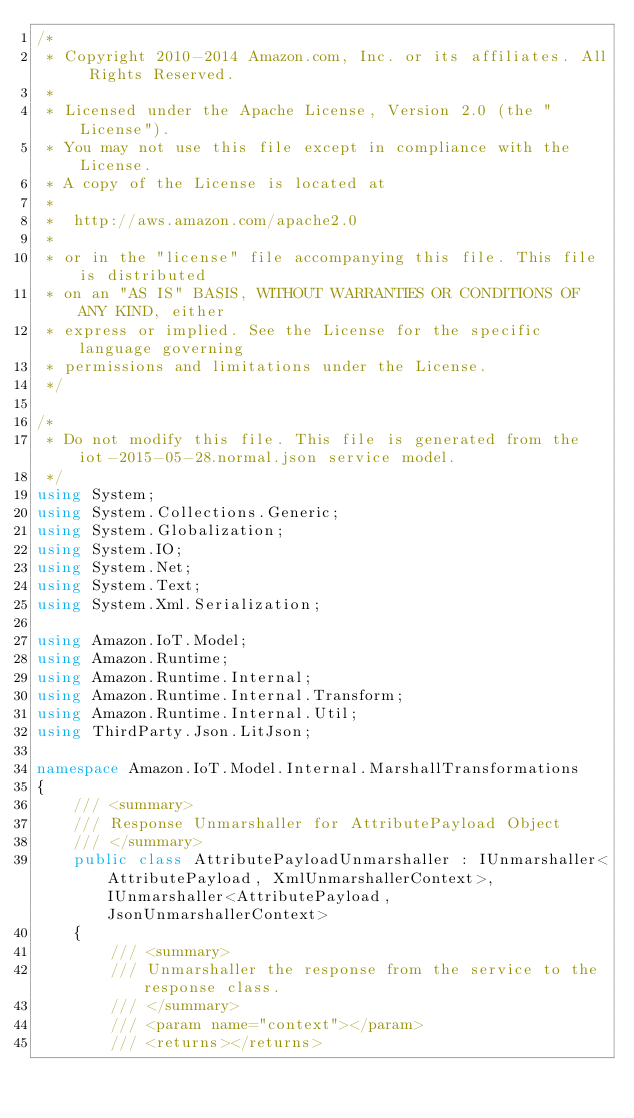<code> <loc_0><loc_0><loc_500><loc_500><_C#_>/*
 * Copyright 2010-2014 Amazon.com, Inc. or its affiliates. All Rights Reserved.
 * 
 * Licensed under the Apache License, Version 2.0 (the "License").
 * You may not use this file except in compliance with the License.
 * A copy of the License is located at
 * 
 *  http://aws.amazon.com/apache2.0
 * 
 * or in the "license" file accompanying this file. This file is distributed
 * on an "AS IS" BASIS, WITHOUT WARRANTIES OR CONDITIONS OF ANY KIND, either
 * express or implied. See the License for the specific language governing
 * permissions and limitations under the License.
 */

/*
 * Do not modify this file. This file is generated from the iot-2015-05-28.normal.json service model.
 */
using System;
using System.Collections.Generic;
using System.Globalization;
using System.IO;
using System.Net;
using System.Text;
using System.Xml.Serialization;

using Amazon.IoT.Model;
using Amazon.Runtime;
using Amazon.Runtime.Internal;
using Amazon.Runtime.Internal.Transform;
using Amazon.Runtime.Internal.Util;
using ThirdParty.Json.LitJson;

namespace Amazon.IoT.Model.Internal.MarshallTransformations
{
    /// <summary>
    /// Response Unmarshaller for AttributePayload Object
    /// </summary>  
    public class AttributePayloadUnmarshaller : IUnmarshaller<AttributePayload, XmlUnmarshallerContext>, IUnmarshaller<AttributePayload, JsonUnmarshallerContext>
    {
        /// <summary>
        /// Unmarshaller the response from the service to the response class.
        /// </summary>  
        /// <param name="context"></param>
        /// <returns></returns></code> 